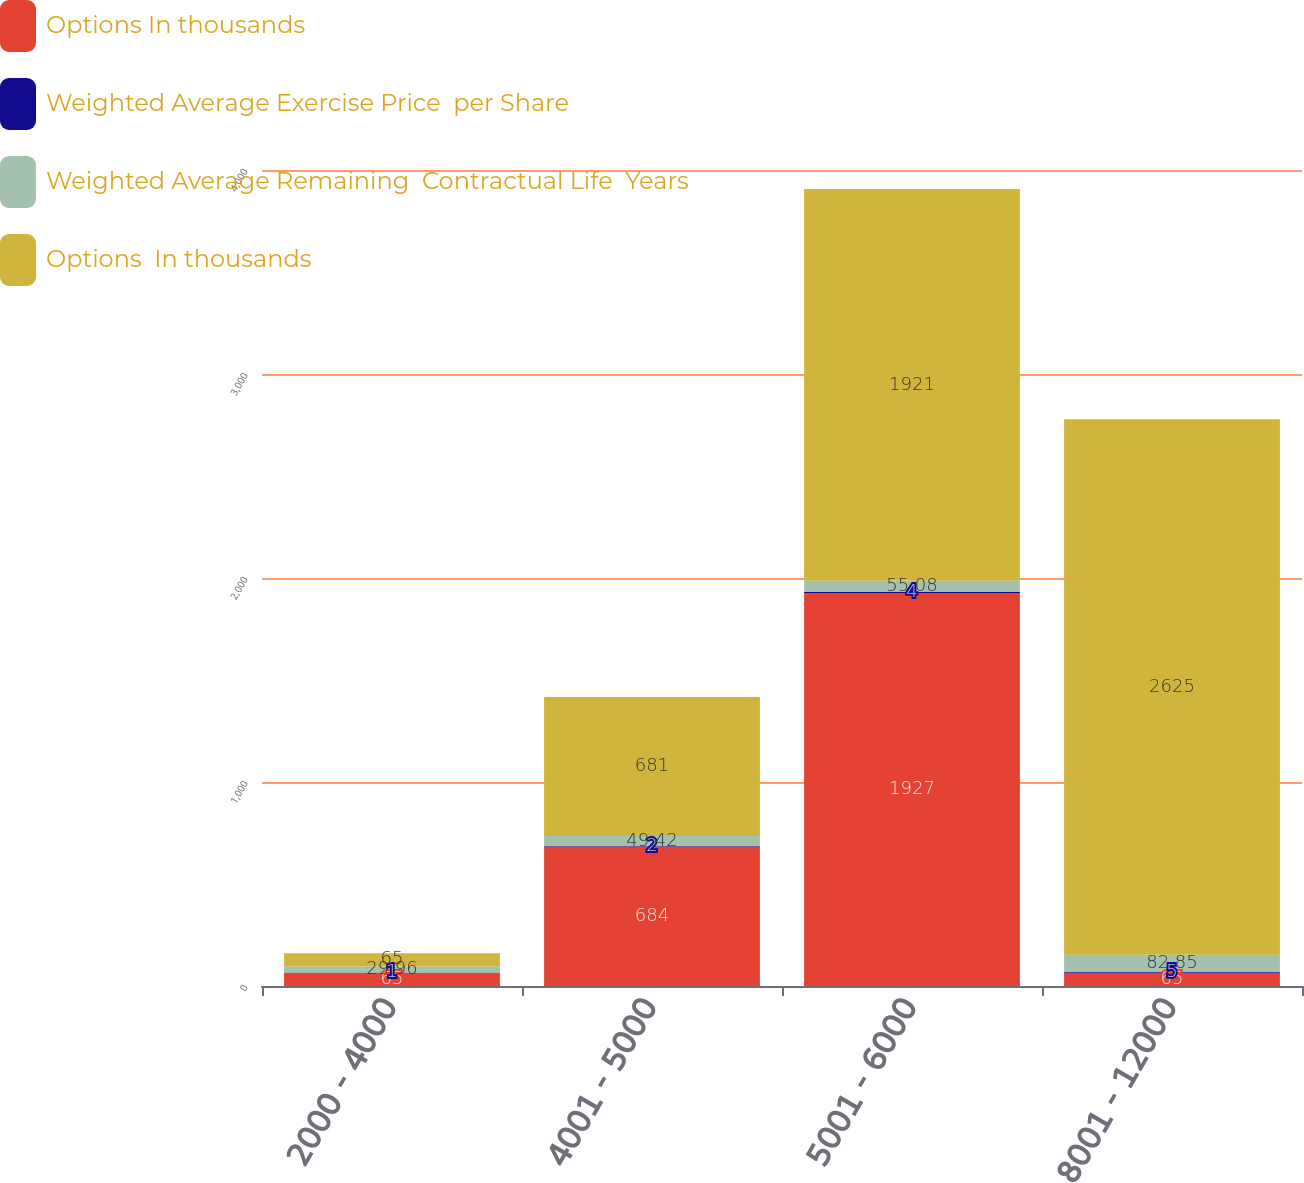Convert chart. <chart><loc_0><loc_0><loc_500><loc_500><stacked_bar_chart><ecel><fcel>2000 - 4000<fcel>4001 - 5000<fcel>5001 - 6000<fcel>8001 - 12000<nl><fcel>Options In thousands<fcel>65<fcel>684<fcel>1927<fcel>65<nl><fcel>Weighted Average Exercise Price  per Share<fcel>1<fcel>2<fcel>4<fcel>5<nl><fcel>Weighted Average Remaining  Contractual Life  Years<fcel>29.96<fcel>49.42<fcel>55.08<fcel>82.85<nl><fcel>Options  In thousands<fcel>65<fcel>681<fcel>1921<fcel>2625<nl></chart> 